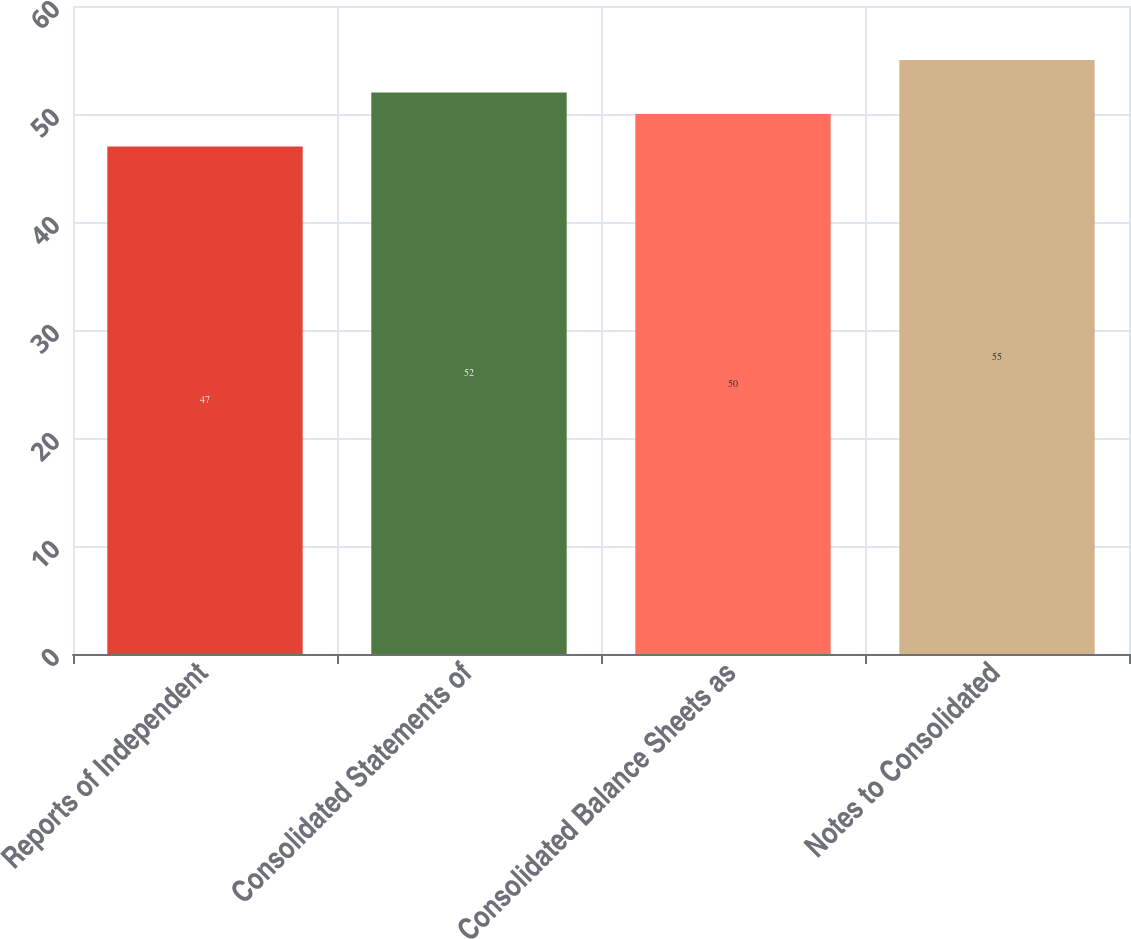Convert chart to OTSL. <chart><loc_0><loc_0><loc_500><loc_500><bar_chart><fcel>Reports of Independent<fcel>Consolidated Statements of<fcel>Consolidated Balance Sheets as<fcel>Notes to Consolidated<nl><fcel>47<fcel>52<fcel>50<fcel>55<nl></chart> 